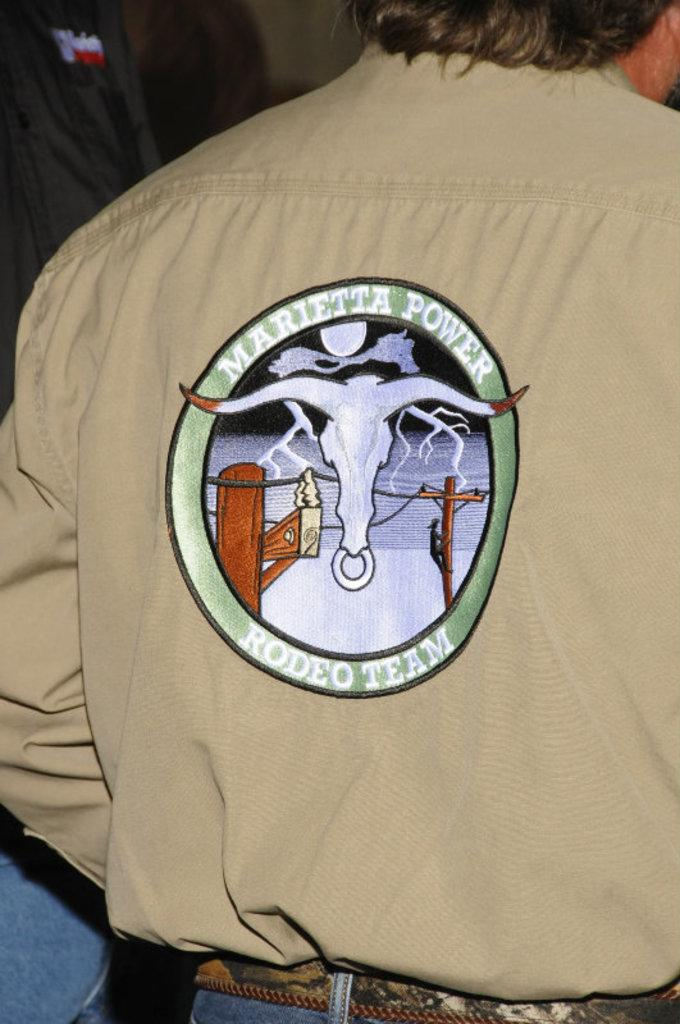<image>
Provide a brief description of the given image. A patch for the Marrietta Power Rodeo Team, circular on the back of a tan shirt. 